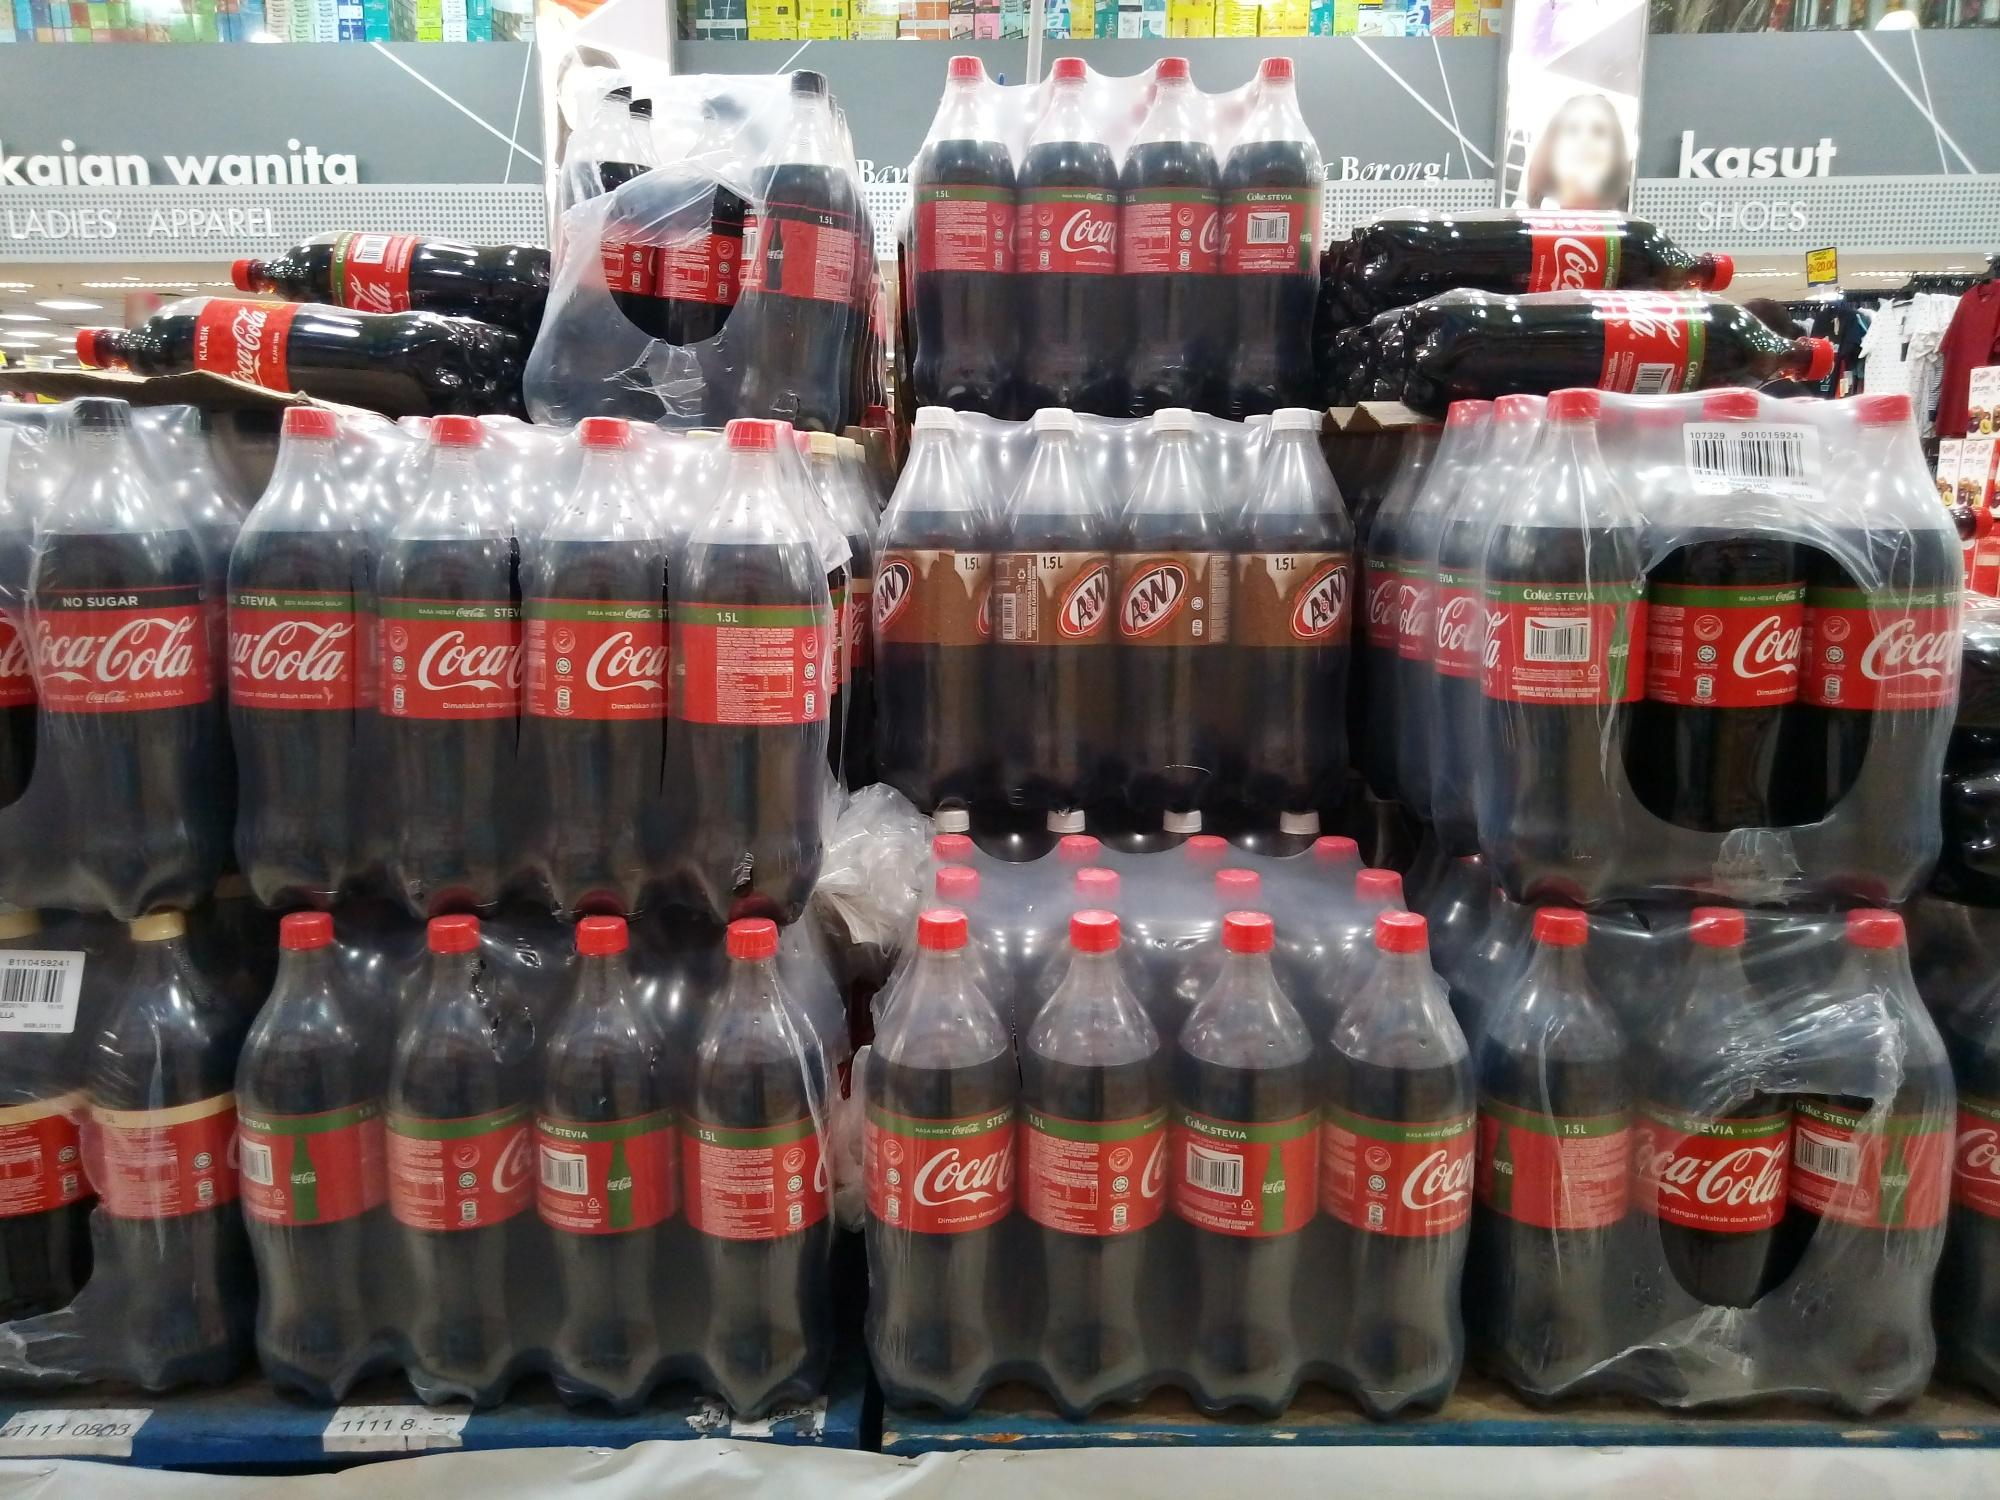If you were to design a marketing campaign based on this image, what elements would you highlight and why? A marketing campaign inspired by this image would emphasize the theme of unity and celebration. The neat arrangement of Coca-Cola and A&W bottles can symbolize togetherness and shared moments. The campaign could feature taglines like 'Join the Celebration,' showcasing diverse groups of people coming together over a bottle of Coca-Cola or A&W. The vibrant labels and uniform display will be highlighted, emphasizing brand consistency and the joy of sharing a familiar, beloved beverage. Additionally, integrating the bustling retail environment as a backdrop will underline the availability and convenience of these products, appealing to a broad customer base and encouraging spontaneous, joyful gatherings. 